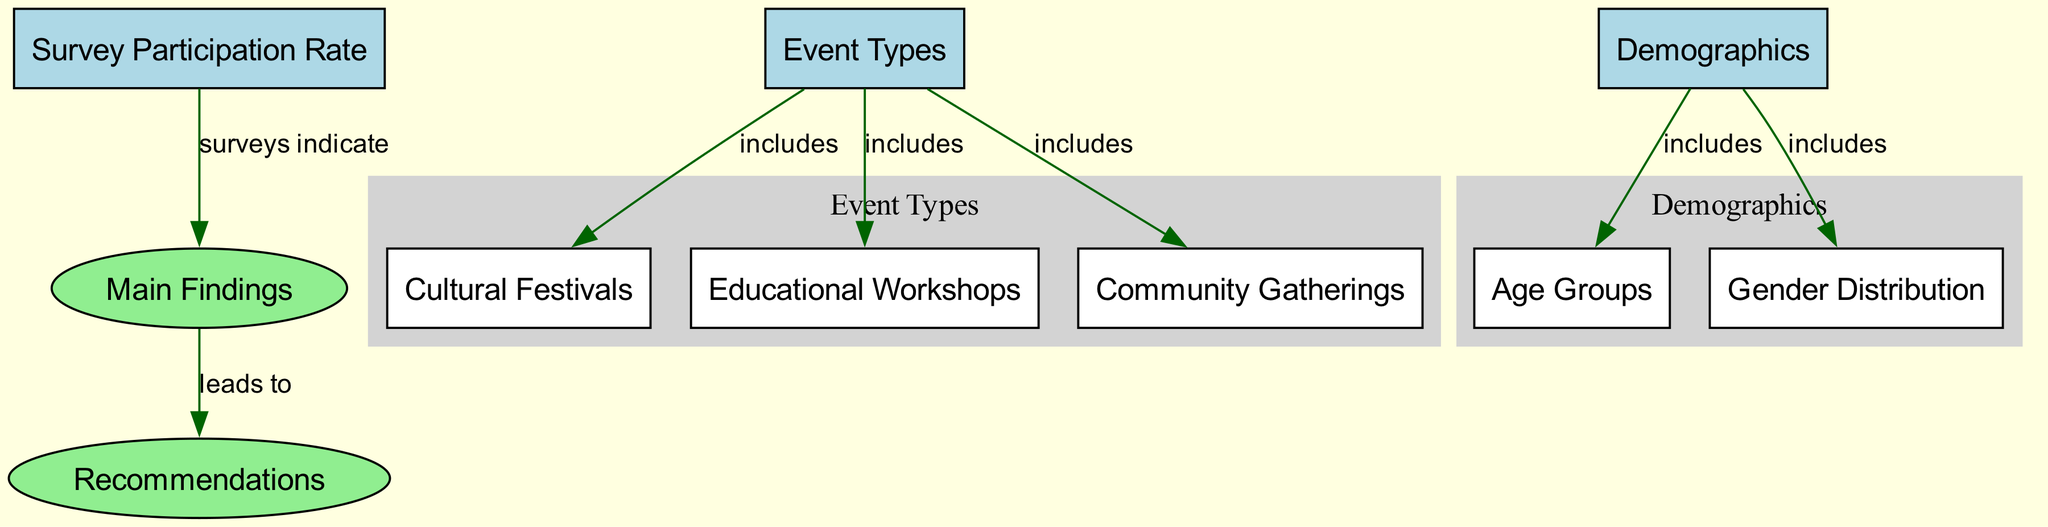What is the main focus of the survey? The diagram indicates that the surveys focus on "Survey Participation Rate," as this is the primary node leading to "Main Findings." This relationship suggests that the participation rate directly informs the survey's conclusions.
Answer: Survey Participation Rate How many event types are included in the diagram? The diagram has three different event types listed under "Event Types," which are "Cultural Festivals," "Educational Workshops," and "Community Gatherings." This makes a total of three event types.
Answer: 3 Which demographic category is included in the survey results? In the diagram, "Demographics" is connected to two categories: "Age Groups" and "Gender Distribution." These represent the demographic aspects considered in the survey.
Answer: Age Groups, Gender Distribution What leads to the recommendations? The edge from "Main Findings" to "Recommendations" indicates that the main findings of the survey directly inform the recommendations proposed within the diagram. This creates a straightforward logical flow from results to suggested actions.
Answer: Main Findings What is included in the "Event Types"? The node labeled "Event Types" includes three specific types: "Cultural Festivals," "Educational Workshops," and "Community Gatherings." These are explicitly recognized as part of the events surveyed.
Answer: Cultural Festivals, Educational Workshops, Community Gatherings What are the categories under demographics? The "Demographics" node is linked to two specific categories: "Age Groups" and "Gender Distribution." This illustrates the demographic factors surveyed in relation to community events.
Answer: Age Groups, Gender Distribution How does the participation rate relate to the main findings? The diagram clearly shows an edge connecting "Survey Participation Rate" directly to "Main Findings." This indicates that the participation rate data is fundamental in drawing the main conclusions of the survey.
Answer: connects directly What action is suggested based on the main findings? The connection from "Main Findings" to "Recommendations" indicates that specific actions or recommendations are derived from analyzing the findings of the survey. Therefore, the actions are informed by survey results.
Answer: Recommendations What color represents the nodes related to demographics? In the diagram, the nodes under "Demographics," including "Age Groups" and "Gender Distribution," are depicted in light grey, which distinguishes them from other categories.
Answer: light grey 